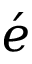<formula> <loc_0><loc_0><loc_500><loc_500>\acute { e }</formula> 